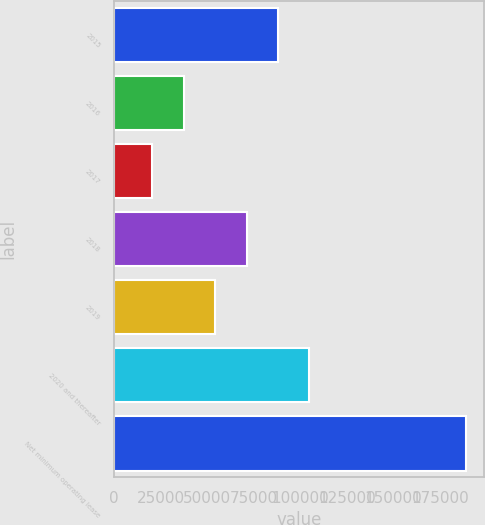Convert chart to OTSL. <chart><loc_0><loc_0><loc_500><loc_500><bar_chart><fcel>2015<fcel>2016<fcel>2017<fcel>2018<fcel>2019<fcel>2020 and thereafter<fcel>Net minimum operating lease<nl><fcel>88057.2<fcel>37396.8<fcel>20510<fcel>71170.4<fcel>54283.6<fcel>104944<fcel>189378<nl></chart> 